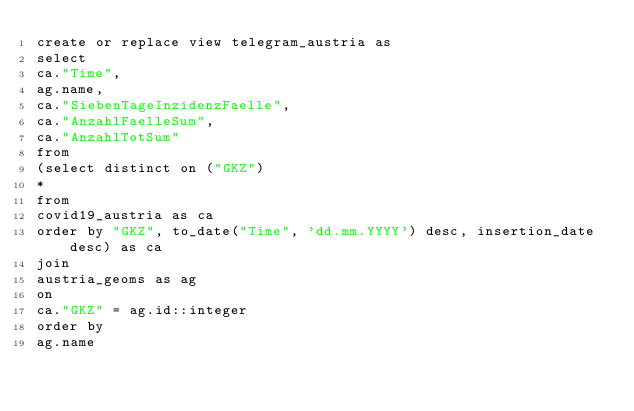<code> <loc_0><loc_0><loc_500><loc_500><_SQL_>create or replace view telegram_austria as
select
ca."Time",
ag.name,
ca."SiebenTageInzidenzFaelle",
ca."AnzahlFaelleSum",
ca."AnzahlTotSum"
from
(select distinct on ("GKZ")
*
from
covid19_austria as ca
order by "GKZ", to_date("Time", 'dd.mm.YYYY') desc, insertion_date desc) as ca
join
austria_geoms as ag
on
ca."GKZ" = ag.id::integer
order by
ag.name</code> 